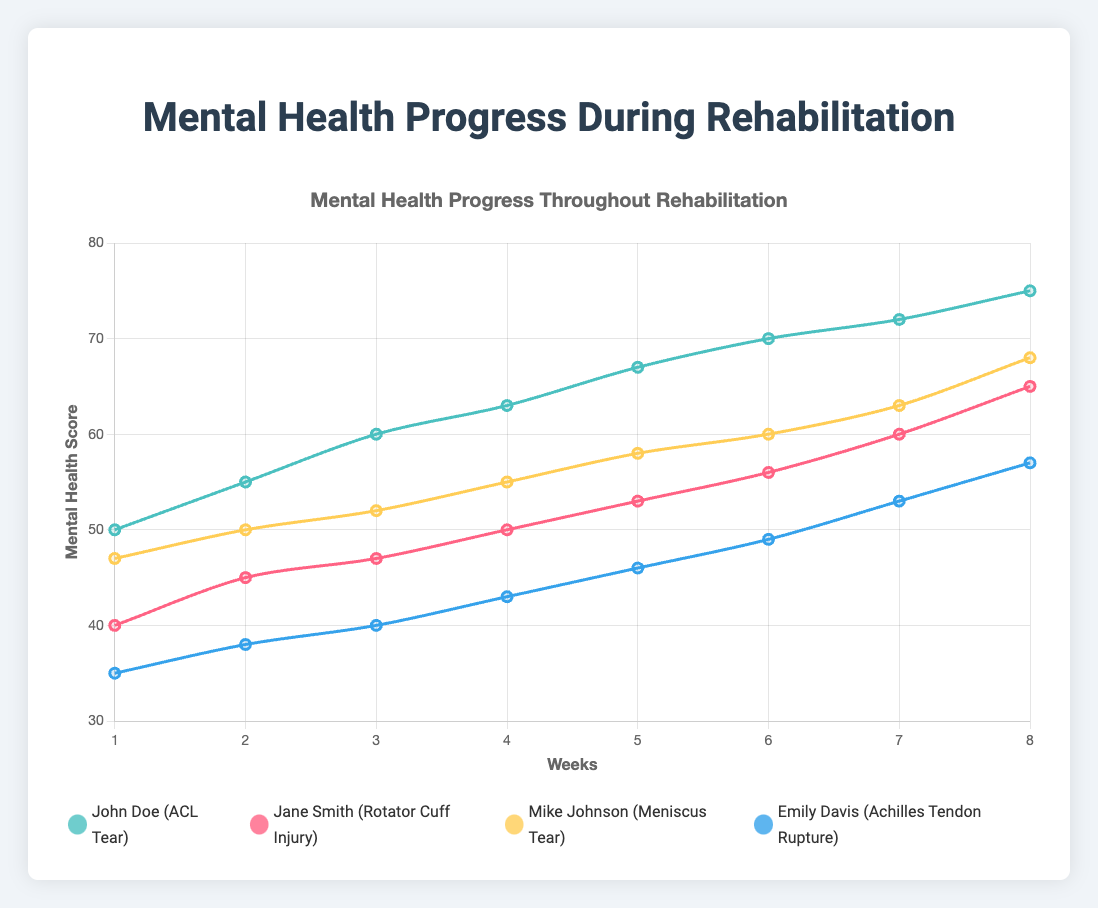Which patient showed the highest mental health score in week 8? To find the highest mental health score in week 8, look for the highest data point in week 8 among all patients. John Doe has a score of 75, Jane Smith has 65, Mike Johnson has 68, and Emily Davis has 57. The highest is John Doe with a score of 75.
Answer: John Doe How much did Jane Smith's mental health score improve from week 1 to week 8? Subtract Jane's mental health score in week 1 from her score in week 8. Week 8 score (65) - Week 1 score (40) = 25. Therefore, Jane's mental health score improved by 25 points.
Answer: 25 points Who had the lowest mental health score initially, and what was it? Compare the week 1 mental health scores of all patients. John Doe has 50, Jane Smith has 40, Mike Johnson has 47, and Emily Davis has 35. Emily Davis had the lowest initial score of 35.
Answer: Emily Davis, 35 Which two patients had the closest mental health scores in week 4, and what were their scores? Compare the scores of all patients in week 4 to find the smallest difference. John Doe: 63, Jane Smith: 50, Mike Johnson: 55, Emily Davis: 43. The closest scores are Mike Johnson (55) and Jane Smith (50), with a difference of 5.
Answer: Mike Johnson (55) and Jane Smith (50) On average, which patient's mental health score increased the fastest per week? Calculate the weekly increases for each patient and find the average increase. 
- John Doe: (75-50)/8 ≈ 3.13
- Jane Smith: (65-40)/8 ≈ 3.13
- Mike Johnson: (68-47)/8 ≈ 2.63
- Emily Davis: (57-35)/8 ≈ 2.75
John Doe and Jane Smith had the highest average weekly increase.
Answer: John Doe and Jane Smith Which patient showed the most consistent growth (minimal variation) in mental health score over the 8 weeks? Check the increments between weeks for each patient. Consistent growth means smaller and more uniform changes. By comparing:
- John Doe's increments: 5, 5, 3, 4, 3, 2, 3
- Jane Smith's increments: 5, 2, 3, 3, 3, 4, 5
- Mike Johnson's increments: 3, 2, 3, 3, 2, 3, 5
- Emily Davis's increments: 3, 2, 3, 3, 3, 4
Emily Davis shows the smallest variation in increments.
Answer: Emily Davis Were any patients' mental health scores equal at any point during the 8 weeks? Compare the mental health scores for every week across all patients. For example:
- Week 1: 50, 40, 47, 35
- Week 2: 55, 45, 50, 38
  ...
- Week 6: 70, 56, 60, 49
Examining all weeks, no two patients' scores are the same at any point.
Answer: No From week 4 to week 8, which patient's mental health score increased the least? Calculate the change in mental health scores from week 4 to week 8.
- John Doe: 75-63 = 12
- Jane Smith: 65-50 = 15
- Mike Johnson: 68-55 = 13
- Emily Davis: 57-43 = 14
The smallest increase is by John Doe, with 12 points.
Answer: John Doe 